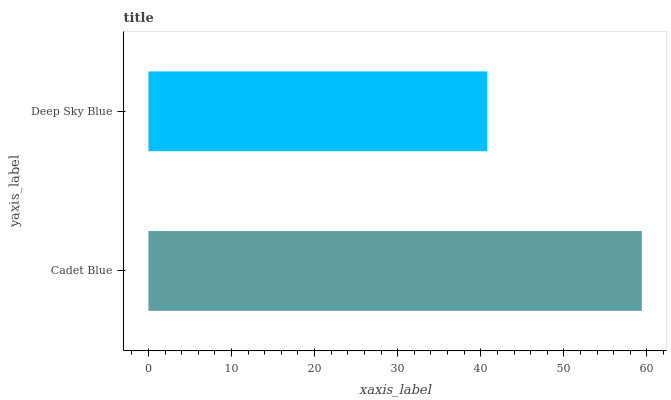Is Deep Sky Blue the minimum?
Answer yes or no. Yes. Is Cadet Blue the maximum?
Answer yes or no. Yes. Is Deep Sky Blue the maximum?
Answer yes or no. No. Is Cadet Blue greater than Deep Sky Blue?
Answer yes or no. Yes. Is Deep Sky Blue less than Cadet Blue?
Answer yes or no. Yes. Is Deep Sky Blue greater than Cadet Blue?
Answer yes or no. No. Is Cadet Blue less than Deep Sky Blue?
Answer yes or no. No. Is Cadet Blue the high median?
Answer yes or no. Yes. Is Deep Sky Blue the low median?
Answer yes or no. Yes. Is Deep Sky Blue the high median?
Answer yes or no. No. Is Cadet Blue the low median?
Answer yes or no. No. 